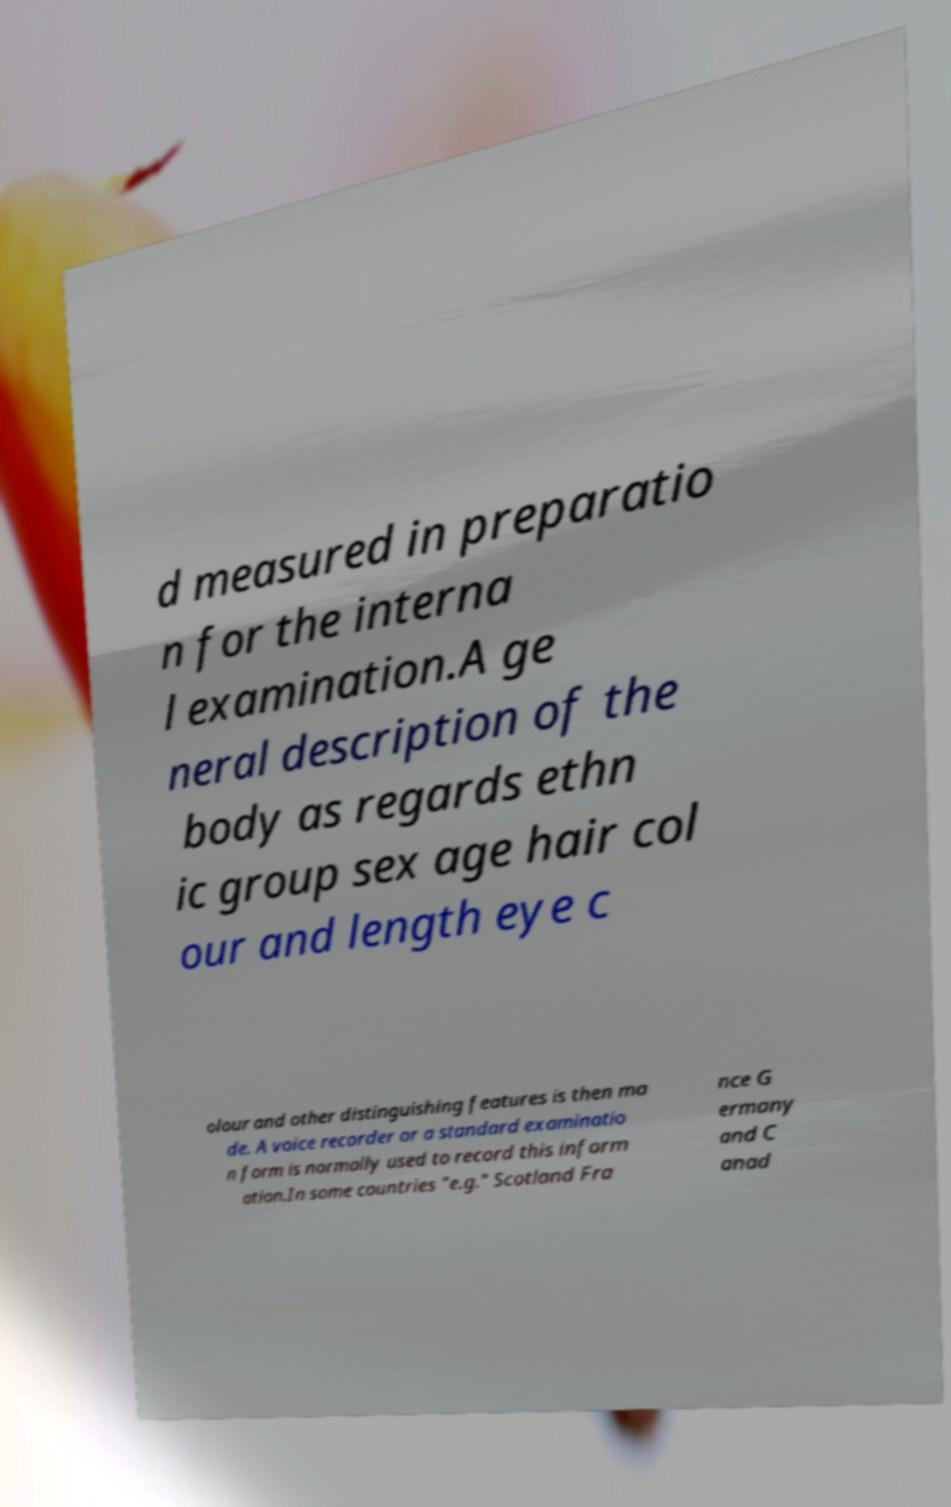Please identify and transcribe the text found in this image. d measured in preparatio n for the interna l examination.A ge neral description of the body as regards ethn ic group sex age hair col our and length eye c olour and other distinguishing features is then ma de. A voice recorder or a standard examinatio n form is normally used to record this inform ation.In some countries "e.g." Scotland Fra nce G ermany and C anad 